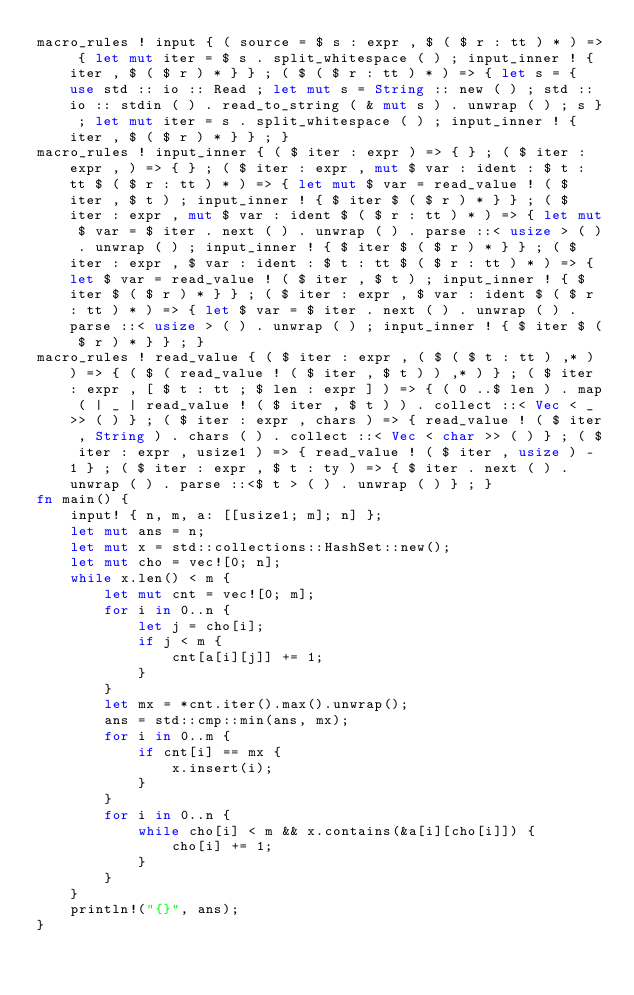Convert code to text. <code><loc_0><loc_0><loc_500><loc_500><_Rust_>macro_rules ! input { ( source = $ s : expr , $ ( $ r : tt ) * ) => { let mut iter = $ s . split_whitespace ( ) ; input_inner ! { iter , $ ( $ r ) * } } ; ( $ ( $ r : tt ) * ) => { let s = { use std :: io :: Read ; let mut s = String :: new ( ) ; std :: io :: stdin ( ) . read_to_string ( & mut s ) . unwrap ( ) ; s } ; let mut iter = s . split_whitespace ( ) ; input_inner ! { iter , $ ( $ r ) * } } ; }
macro_rules ! input_inner { ( $ iter : expr ) => { } ; ( $ iter : expr , ) => { } ; ( $ iter : expr , mut $ var : ident : $ t : tt $ ( $ r : tt ) * ) => { let mut $ var = read_value ! ( $ iter , $ t ) ; input_inner ! { $ iter $ ( $ r ) * } } ; ( $ iter : expr , mut $ var : ident $ ( $ r : tt ) * ) => { let mut $ var = $ iter . next ( ) . unwrap ( ) . parse ::< usize > ( ) . unwrap ( ) ; input_inner ! { $ iter $ ( $ r ) * } } ; ( $ iter : expr , $ var : ident : $ t : tt $ ( $ r : tt ) * ) => { let $ var = read_value ! ( $ iter , $ t ) ; input_inner ! { $ iter $ ( $ r ) * } } ; ( $ iter : expr , $ var : ident $ ( $ r : tt ) * ) => { let $ var = $ iter . next ( ) . unwrap ( ) . parse ::< usize > ( ) . unwrap ( ) ; input_inner ! { $ iter $ ( $ r ) * } } ; }
macro_rules ! read_value { ( $ iter : expr , ( $ ( $ t : tt ) ,* ) ) => { ( $ ( read_value ! ( $ iter , $ t ) ) ,* ) } ; ( $ iter : expr , [ $ t : tt ; $ len : expr ] ) => { ( 0 ..$ len ) . map ( | _ | read_value ! ( $ iter , $ t ) ) . collect ::< Vec < _ >> ( ) } ; ( $ iter : expr , chars ) => { read_value ! ( $ iter , String ) . chars ( ) . collect ::< Vec < char >> ( ) } ; ( $ iter : expr , usize1 ) => { read_value ! ( $ iter , usize ) - 1 } ; ( $ iter : expr , $ t : ty ) => { $ iter . next ( ) . unwrap ( ) . parse ::<$ t > ( ) . unwrap ( ) } ; }
fn main() {
    input! { n, m, a: [[usize1; m]; n] };
    let mut ans = n;
    let mut x = std::collections::HashSet::new();
    let mut cho = vec![0; n];
    while x.len() < m {
        let mut cnt = vec![0; m];
        for i in 0..n {
            let j = cho[i];
            if j < m {
                cnt[a[i][j]] += 1;
            }
        }
        let mx = *cnt.iter().max().unwrap();
        ans = std::cmp::min(ans, mx);
        for i in 0..m {
            if cnt[i] == mx {
                x.insert(i);
            }
        }
        for i in 0..n {
            while cho[i] < m && x.contains(&a[i][cho[i]]) {
                cho[i] += 1;
            }
        }
    }
    println!("{}", ans);
}
</code> 